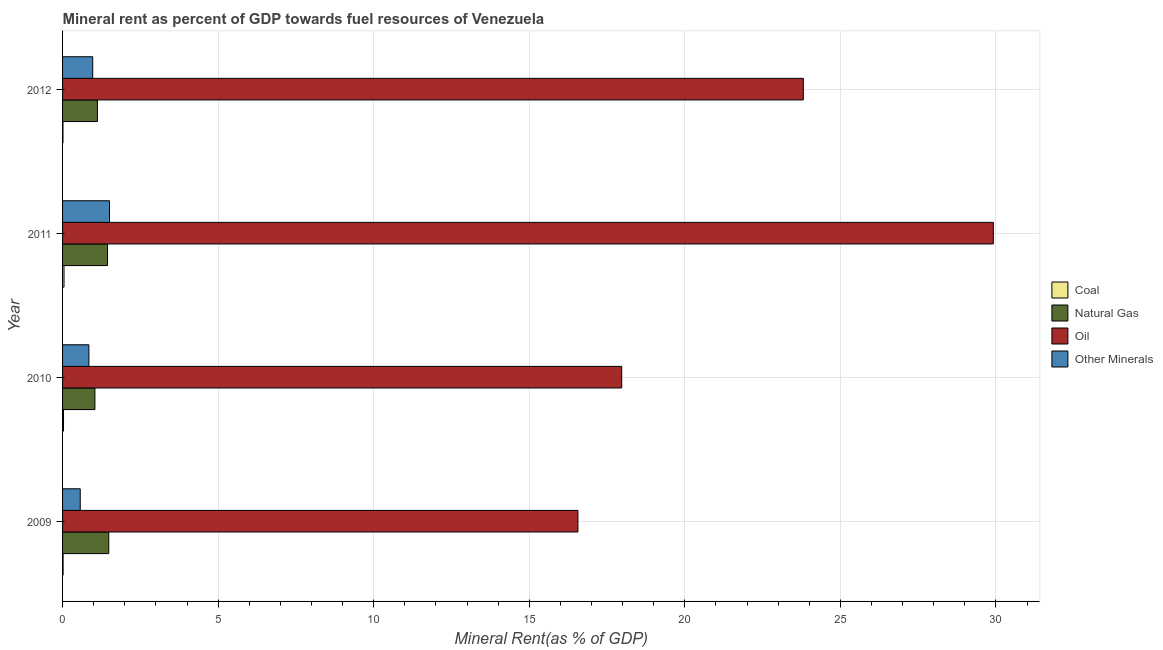How many bars are there on the 3rd tick from the top?
Offer a very short reply. 4. How many bars are there on the 1st tick from the bottom?
Ensure brevity in your answer.  4. In how many cases, is the number of bars for a given year not equal to the number of legend labels?
Your answer should be very brief. 0. What is the coal rent in 2010?
Make the answer very short. 0.03. Across all years, what is the maximum  rent of other minerals?
Keep it short and to the point. 1.51. Across all years, what is the minimum oil rent?
Keep it short and to the point. 16.57. In which year was the  rent of other minerals maximum?
Make the answer very short. 2011. What is the total natural gas rent in the graph?
Your answer should be very brief. 5.09. What is the difference between the natural gas rent in 2011 and that in 2012?
Offer a very short reply. 0.32. What is the difference between the oil rent in 2009 and the natural gas rent in 2010?
Give a very brief answer. 15.53. What is the average natural gas rent per year?
Keep it short and to the point. 1.27. In the year 2010, what is the difference between the oil rent and  rent of other minerals?
Your answer should be compact. 17.13. What is the ratio of the coal rent in 2010 to that in 2011?
Ensure brevity in your answer.  0.66. Is the difference between the coal rent in 2009 and 2011 greater than the difference between the  rent of other minerals in 2009 and 2011?
Keep it short and to the point. Yes. What is the difference between the highest and the second highest  rent of other minerals?
Provide a short and direct response. 0.54. What is the difference between the highest and the lowest  rent of other minerals?
Offer a terse response. 0.94. In how many years, is the coal rent greater than the average coal rent taken over all years?
Offer a terse response. 2. Is the sum of the  rent of other minerals in 2011 and 2012 greater than the maximum natural gas rent across all years?
Provide a short and direct response. Yes. What does the 3rd bar from the top in 2011 represents?
Ensure brevity in your answer.  Natural Gas. What does the 2nd bar from the bottom in 2010 represents?
Your answer should be very brief. Natural Gas. How many bars are there?
Your answer should be compact. 16. Are all the bars in the graph horizontal?
Offer a terse response. Yes. How many years are there in the graph?
Your answer should be very brief. 4. What is the difference between two consecutive major ticks on the X-axis?
Give a very brief answer. 5. Does the graph contain any zero values?
Your answer should be very brief. No. Does the graph contain grids?
Your answer should be compact. Yes. Where does the legend appear in the graph?
Provide a succinct answer. Center right. How many legend labels are there?
Keep it short and to the point. 4. What is the title of the graph?
Your answer should be compact. Mineral rent as percent of GDP towards fuel resources of Venezuela. What is the label or title of the X-axis?
Your response must be concise. Mineral Rent(as % of GDP). What is the label or title of the Y-axis?
Provide a short and direct response. Year. What is the Mineral Rent(as % of GDP) in Coal in 2009?
Provide a short and direct response. 0.02. What is the Mineral Rent(as % of GDP) in Natural Gas in 2009?
Keep it short and to the point. 1.48. What is the Mineral Rent(as % of GDP) in Oil in 2009?
Your response must be concise. 16.57. What is the Mineral Rent(as % of GDP) of Other Minerals in 2009?
Your response must be concise. 0.57. What is the Mineral Rent(as % of GDP) of Coal in 2010?
Ensure brevity in your answer.  0.03. What is the Mineral Rent(as % of GDP) of Natural Gas in 2010?
Make the answer very short. 1.04. What is the Mineral Rent(as % of GDP) in Oil in 2010?
Give a very brief answer. 17.97. What is the Mineral Rent(as % of GDP) of Other Minerals in 2010?
Make the answer very short. 0.85. What is the Mineral Rent(as % of GDP) of Coal in 2011?
Provide a succinct answer. 0.05. What is the Mineral Rent(as % of GDP) in Natural Gas in 2011?
Your response must be concise. 1.45. What is the Mineral Rent(as % of GDP) of Oil in 2011?
Ensure brevity in your answer.  29.92. What is the Mineral Rent(as % of GDP) in Other Minerals in 2011?
Provide a succinct answer. 1.51. What is the Mineral Rent(as % of GDP) of Coal in 2012?
Ensure brevity in your answer.  0.01. What is the Mineral Rent(as % of GDP) in Natural Gas in 2012?
Your answer should be very brief. 1.12. What is the Mineral Rent(as % of GDP) of Oil in 2012?
Make the answer very short. 23.81. What is the Mineral Rent(as % of GDP) in Other Minerals in 2012?
Offer a terse response. 0.97. Across all years, what is the maximum Mineral Rent(as % of GDP) of Coal?
Provide a short and direct response. 0.05. Across all years, what is the maximum Mineral Rent(as % of GDP) of Natural Gas?
Your answer should be very brief. 1.48. Across all years, what is the maximum Mineral Rent(as % of GDP) in Oil?
Ensure brevity in your answer.  29.92. Across all years, what is the maximum Mineral Rent(as % of GDP) of Other Minerals?
Your answer should be compact. 1.51. Across all years, what is the minimum Mineral Rent(as % of GDP) in Coal?
Ensure brevity in your answer.  0.01. Across all years, what is the minimum Mineral Rent(as % of GDP) of Natural Gas?
Offer a terse response. 1.04. Across all years, what is the minimum Mineral Rent(as % of GDP) in Oil?
Make the answer very short. 16.57. Across all years, what is the minimum Mineral Rent(as % of GDP) of Other Minerals?
Your answer should be very brief. 0.57. What is the total Mineral Rent(as % of GDP) of Coal in the graph?
Offer a terse response. 0.11. What is the total Mineral Rent(as % of GDP) of Natural Gas in the graph?
Your answer should be very brief. 5.09. What is the total Mineral Rent(as % of GDP) of Oil in the graph?
Give a very brief answer. 88.27. What is the total Mineral Rent(as % of GDP) of Other Minerals in the graph?
Give a very brief answer. 3.89. What is the difference between the Mineral Rent(as % of GDP) of Coal in 2009 and that in 2010?
Make the answer very short. -0.01. What is the difference between the Mineral Rent(as % of GDP) of Natural Gas in 2009 and that in 2010?
Your answer should be very brief. 0.45. What is the difference between the Mineral Rent(as % of GDP) in Oil in 2009 and that in 2010?
Provide a succinct answer. -1.41. What is the difference between the Mineral Rent(as % of GDP) in Other Minerals in 2009 and that in 2010?
Your answer should be compact. -0.28. What is the difference between the Mineral Rent(as % of GDP) of Coal in 2009 and that in 2011?
Offer a terse response. -0.03. What is the difference between the Mineral Rent(as % of GDP) in Natural Gas in 2009 and that in 2011?
Provide a short and direct response. 0.04. What is the difference between the Mineral Rent(as % of GDP) in Oil in 2009 and that in 2011?
Make the answer very short. -13.35. What is the difference between the Mineral Rent(as % of GDP) in Other Minerals in 2009 and that in 2011?
Provide a succinct answer. -0.94. What is the difference between the Mineral Rent(as % of GDP) in Coal in 2009 and that in 2012?
Give a very brief answer. 0. What is the difference between the Mineral Rent(as % of GDP) in Natural Gas in 2009 and that in 2012?
Make the answer very short. 0.36. What is the difference between the Mineral Rent(as % of GDP) in Oil in 2009 and that in 2012?
Your answer should be very brief. -7.24. What is the difference between the Mineral Rent(as % of GDP) in Other Minerals in 2009 and that in 2012?
Offer a very short reply. -0.4. What is the difference between the Mineral Rent(as % of GDP) in Coal in 2010 and that in 2011?
Provide a short and direct response. -0.02. What is the difference between the Mineral Rent(as % of GDP) of Natural Gas in 2010 and that in 2011?
Make the answer very short. -0.41. What is the difference between the Mineral Rent(as % of GDP) in Oil in 2010 and that in 2011?
Your answer should be very brief. -11.94. What is the difference between the Mineral Rent(as % of GDP) of Other Minerals in 2010 and that in 2011?
Provide a succinct answer. -0.66. What is the difference between the Mineral Rent(as % of GDP) in Coal in 2010 and that in 2012?
Provide a succinct answer. 0.02. What is the difference between the Mineral Rent(as % of GDP) in Natural Gas in 2010 and that in 2012?
Offer a very short reply. -0.08. What is the difference between the Mineral Rent(as % of GDP) in Oil in 2010 and that in 2012?
Offer a terse response. -5.84. What is the difference between the Mineral Rent(as % of GDP) of Other Minerals in 2010 and that in 2012?
Keep it short and to the point. -0.12. What is the difference between the Mineral Rent(as % of GDP) in Coal in 2011 and that in 2012?
Keep it short and to the point. 0.03. What is the difference between the Mineral Rent(as % of GDP) of Natural Gas in 2011 and that in 2012?
Your response must be concise. 0.32. What is the difference between the Mineral Rent(as % of GDP) in Oil in 2011 and that in 2012?
Your answer should be very brief. 6.11. What is the difference between the Mineral Rent(as % of GDP) in Other Minerals in 2011 and that in 2012?
Your response must be concise. 0.54. What is the difference between the Mineral Rent(as % of GDP) in Coal in 2009 and the Mineral Rent(as % of GDP) in Natural Gas in 2010?
Offer a terse response. -1.02. What is the difference between the Mineral Rent(as % of GDP) in Coal in 2009 and the Mineral Rent(as % of GDP) in Oil in 2010?
Provide a succinct answer. -17.95. What is the difference between the Mineral Rent(as % of GDP) in Coal in 2009 and the Mineral Rent(as % of GDP) in Other Minerals in 2010?
Offer a very short reply. -0.83. What is the difference between the Mineral Rent(as % of GDP) in Natural Gas in 2009 and the Mineral Rent(as % of GDP) in Oil in 2010?
Provide a short and direct response. -16.49. What is the difference between the Mineral Rent(as % of GDP) of Natural Gas in 2009 and the Mineral Rent(as % of GDP) of Other Minerals in 2010?
Ensure brevity in your answer.  0.64. What is the difference between the Mineral Rent(as % of GDP) in Oil in 2009 and the Mineral Rent(as % of GDP) in Other Minerals in 2010?
Give a very brief answer. 15.72. What is the difference between the Mineral Rent(as % of GDP) of Coal in 2009 and the Mineral Rent(as % of GDP) of Natural Gas in 2011?
Ensure brevity in your answer.  -1.43. What is the difference between the Mineral Rent(as % of GDP) of Coal in 2009 and the Mineral Rent(as % of GDP) of Oil in 2011?
Your answer should be very brief. -29.9. What is the difference between the Mineral Rent(as % of GDP) of Coal in 2009 and the Mineral Rent(as % of GDP) of Other Minerals in 2011?
Make the answer very short. -1.49. What is the difference between the Mineral Rent(as % of GDP) in Natural Gas in 2009 and the Mineral Rent(as % of GDP) in Oil in 2011?
Your answer should be compact. -28.43. What is the difference between the Mineral Rent(as % of GDP) of Natural Gas in 2009 and the Mineral Rent(as % of GDP) of Other Minerals in 2011?
Provide a short and direct response. -0.02. What is the difference between the Mineral Rent(as % of GDP) of Oil in 2009 and the Mineral Rent(as % of GDP) of Other Minerals in 2011?
Offer a very short reply. 15.06. What is the difference between the Mineral Rent(as % of GDP) of Coal in 2009 and the Mineral Rent(as % of GDP) of Natural Gas in 2012?
Make the answer very short. -1.1. What is the difference between the Mineral Rent(as % of GDP) in Coal in 2009 and the Mineral Rent(as % of GDP) in Oil in 2012?
Your answer should be very brief. -23.79. What is the difference between the Mineral Rent(as % of GDP) in Coal in 2009 and the Mineral Rent(as % of GDP) in Other Minerals in 2012?
Make the answer very short. -0.95. What is the difference between the Mineral Rent(as % of GDP) of Natural Gas in 2009 and the Mineral Rent(as % of GDP) of Oil in 2012?
Provide a short and direct response. -22.32. What is the difference between the Mineral Rent(as % of GDP) in Natural Gas in 2009 and the Mineral Rent(as % of GDP) in Other Minerals in 2012?
Your answer should be very brief. 0.52. What is the difference between the Mineral Rent(as % of GDP) in Oil in 2009 and the Mineral Rent(as % of GDP) in Other Minerals in 2012?
Offer a terse response. 15.6. What is the difference between the Mineral Rent(as % of GDP) of Coal in 2010 and the Mineral Rent(as % of GDP) of Natural Gas in 2011?
Make the answer very short. -1.42. What is the difference between the Mineral Rent(as % of GDP) in Coal in 2010 and the Mineral Rent(as % of GDP) in Oil in 2011?
Give a very brief answer. -29.89. What is the difference between the Mineral Rent(as % of GDP) in Coal in 2010 and the Mineral Rent(as % of GDP) in Other Minerals in 2011?
Provide a short and direct response. -1.48. What is the difference between the Mineral Rent(as % of GDP) of Natural Gas in 2010 and the Mineral Rent(as % of GDP) of Oil in 2011?
Ensure brevity in your answer.  -28.88. What is the difference between the Mineral Rent(as % of GDP) of Natural Gas in 2010 and the Mineral Rent(as % of GDP) of Other Minerals in 2011?
Offer a terse response. -0.47. What is the difference between the Mineral Rent(as % of GDP) in Oil in 2010 and the Mineral Rent(as % of GDP) in Other Minerals in 2011?
Keep it short and to the point. 16.46. What is the difference between the Mineral Rent(as % of GDP) of Coal in 2010 and the Mineral Rent(as % of GDP) of Natural Gas in 2012?
Your response must be concise. -1.09. What is the difference between the Mineral Rent(as % of GDP) of Coal in 2010 and the Mineral Rent(as % of GDP) of Oil in 2012?
Make the answer very short. -23.78. What is the difference between the Mineral Rent(as % of GDP) in Coal in 2010 and the Mineral Rent(as % of GDP) in Other Minerals in 2012?
Keep it short and to the point. -0.94. What is the difference between the Mineral Rent(as % of GDP) in Natural Gas in 2010 and the Mineral Rent(as % of GDP) in Oil in 2012?
Keep it short and to the point. -22.77. What is the difference between the Mineral Rent(as % of GDP) in Natural Gas in 2010 and the Mineral Rent(as % of GDP) in Other Minerals in 2012?
Your response must be concise. 0.07. What is the difference between the Mineral Rent(as % of GDP) in Oil in 2010 and the Mineral Rent(as % of GDP) in Other Minerals in 2012?
Offer a very short reply. 17. What is the difference between the Mineral Rent(as % of GDP) of Coal in 2011 and the Mineral Rent(as % of GDP) of Natural Gas in 2012?
Make the answer very short. -1.08. What is the difference between the Mineral Rent(as % of GDP) of Coal in 2011 and the Mineral Rent(as % of GDP) of Oil in 2012?
Ensure brevity in your answer.  -23.76. What is the difference between the Mineral Rent(as % of GDP) in Coal in 2011 and the Mineral Rent(as % of GDP) in Other Minerals in 2012?
Keep it short and to the point. -0.92. What is the difference between the Mineral Rent(as % of GDP) in Natural Gas in 2011 and the Mineral Rent(as % of GDP) in Oil in 2012?
Provide a short and direct response. -22.36. What is the difference between the Mineral Rent(as % of GDP) in Natural Gas in 2011 and the Mineral Rent(as % of GDP) in Other Minerals in 2012?
Offer a very short reply. 0.48. What is the difference between the Mineral Rent(as % of GDP) in Oil in 2011 and the Mineral Rent(as % of GDP) in Other Minerals in 2012?
Your answer should be compact. 28.95. What is the average Mineral Rent(as % of GDP) of Coal per year?
Provide a succinct answer. 0.03. What is the average Mineral Rent(as % of GDP) in Natural Gas per year?
Provide a short and direct response. 1.27. What is the average Mineral Rent(as % of GDP) of Oil per year?
Offer a terse response. 22.07. What is the average Mineral Rent(as % of GDP) of Other Minerals per year?
Offer a terse response. 0.97. In the year 2009, what is the difference between the Mineral Rent(as % of GDP) of Coal and Mineral Rent(as % of GDP) of Natural Gas?
Give a very brief answer. -1.47. In the year 2009, what is the difference between the Mineral Rent(as % of GDP) in Coal and Mineral Rent(as % of GDP) in Oil?
Give a very brief answer. -16.55. In the year 2009, what is the difference between the Mineral Rent(as % of GDP) in Coal and Mineral Rent(as % of GDP) in Other Minerals?
Provide a short and direct response. -0.55. In the year 2009, what is the difference between the Mineral Rent(as % of GDP) of Natural Gas and Mineral Rent(as % of GDP) of Oil?
Your answer should be very brief. -15.08. In the year 2009, what is the difference between the Mineral Rent(as % of GDP) in Natural Gas and Mineral Rent(as % of GDP) in Other Minerals?
Your answer should be compact. 0.92. In the year 2009, what is the difference between the Mineral Rent(as % of GDP) of Oil and Mineral Rent(as % of GDP) of Other Minerals?
Provide a short and direct response. 16. In the year 2010, what is the difference between the Mineral Rent(as % of GDP) in Coal and Mineral Rent(as % of GDP) in Natural Gas?
Ensure brevity in your answer.  -1.01. In the year 2010, what is the difference between the Mineral Rent(as % of GDP) of Coal and Mineral Rent(as % of GDP) of Oil?
Offer a very short reply. -17.94. In the year 2010, what is the difference between the Mineral Rent(as % of GDP) in Coal and Mineral Rent(as % of GDP) in Other Minerals?
Your answer should be very brief. -0.82. In the year 2010, what is the difference between the Mineral Rent(as % of GDP) of Natural Gas and Mineral Rent(as % of GDP) of Oil?
Make the answer very short. -16.93. In the year 2010, what is the difference between the Mineral Rent(as % of GDP) in Natural Gas and Mineral Rent(as % of GDP) in Other Minerals?
Offer a terse response. 0.19. In the year 2010, what is the difference between the Mineral Rent(as % of GDP) in Oil and Mineral Rent(as % of GDP) in Other Minerals?
Provide a succinct answer. 17.13. In the year 2011, what is the difference between the Mineral Rent(as % of GDP) in Coal and Mineral Rent(as % of GDP) in Natural Gas?
Your answer should be compact. -1.4. In the year 2011, what is the difference between the Mineral Rent(as % of GDP) of Coal and Mineral Rent(as % of GDP) of Oil?
Ensure brevity in your answer.  -29.87. In the year 2011, what is the difference between the Mineral Rent(as % of GDP) of Coal and Mineral Rent(as % of GDP) of Other Minerals?
Your answer should be very brief. -1.46. In the year 2011, what is the difference between the Mineral Rent(as % of GDP) of Natural Gas and Mineral Rent(as % of GDP) of Oil?
Offer a very short reply. -28.47. In the year 2011, what is the difference between the Mineral Rent(as % of GDP) in Natural Gas and Mineral Rent(as % of GDP) in Other Minerals?
Your answer should be very brief. -0.06. In the year 2011, what is the difference between the Mineral Rent(as % of GDP) of Oil and Mineral Rent(as % of GDP) of Other Minerals?
Your answer should be very brief. 28.41. In the year 2012, what is the difference between the Mineral Rent(as % of GDP) of Coal and Mineral Rent(as % of GDP) of Natural Gas?
Your response must be concise. -1.11. In the year 2012, what is the difference between the Mineral Rent(as % of GDP) in Coal and Mineral Rent(as % of GDP) in Oil?
Offer a terse response. -23.8. In the year 2012, what is the difference between the Mineral Rent(as % of GDP) in Coal and Mineral Rent(as % of GDP) in Other Minerals?
Provide a succinct answer. -0.96. In the year 2012, what is the difference between the Mineral Rent(as % of GDP) in Natural Gas and Mineral Rent(as % of GDP) in Oil?
Give a very brief answer. -22.69. In the year 2012, what is the difference between the Mineral Rent(as % of GDP) in Natural Gas and Mineral Rent(as % of GDP) in Other Minerals?
Provide a short and direct response. 0.15. In the year 2012, what is the difference between the Mineral Rent(as % of GDP) of Oil and Mineral Rent(as % of GDP) of Other Minerals?
Your answer should be compact. 22.84. What is the ratio of the Mineral Rent(as % of GDP) in Coal in 2009 to that in 2010?
Your answer should be compact. 0.58. What is the ratio of the Mineral Rent(as % of GDP) in Natural Gas in 2009 to that in 2010?
Make the answer very short. 1.43. What is the ratio of the Mineral Rent(as % of GDP) of Oil in 2009 to that in 2010?
Your answer should be compact. 0.92. What is the ratio of the Mineral Rent(as % of GDP) of Other Minerals in 2009 to that in 2010?
Make the answer very short. 0.67. What is the ratio of the Mineral Rent(as % of GDP) of Coal in 2009 to that in 2011?
Offer a terse response. 0.38. What is the ratio of the Mineral Rent(as % of GDP) in Natural Gas in 2009 to that in 2011?
Offer a terse response. 1.03. What is the ratio of the Mineral Rent(as % of GDP) of Oil in 2009 to that in 2011?
Provide a short and direct response. 0.55. What is the ratio of the Mineral Rent(as % of GDP) in Other Minerals in 2009 to that in 2011?
Give a very brief answer. 0.38. What is the ratio of the Mineral Rent(as % of GDP) of Coal in 2009 to that in 2012?
Provide a succinct answer. 1.36. What is the ratio of the Mineral Rent(as % of GDP) of Natural Gas in 2009 to that in 2012?
Your answer should be very brief. 1.32. What is the ratio of the Mineral Rent(as % of GDP) of Oil in 2009 to that in 2012?
Your answer should be compact. 0.7. What is the ratio of the Mineral Rent(as % of GDP) of Other Minerals in 2009 to that in 2012?
Give a very brief answer. 0.59. What is the ratio of the Mineral Rent(as % of GDP) of Coal in 2010 to that in 2011?
Give a very brief answer. 0.66. What is the ratio of the Mineral Rent(as % of GDP) in Natural Gas in 2010 to that in 2011?
Provide a succinct answer. 0.72. What is the ratio of the Mineral Rent(as % of GDP) of Oil in 2010 to that in 2011?
Keep it short and to the point. 0.6. What is the ratio of the Mineral Rent(as % of GDP) in Other Minerals in 2010 to that in 2011?
Provide a short and direct response. 0.56. What is the ratio of the Mineral Rent(as % of GDP) in Coal in 2010 to that in 2012?
Ensure brevity in your answer.  2.35. What is the ratio of the Mineral Rent(as % of GDP) of Natural Gas in 2010 to that in 2012?
Offer a terse response. 0.93. What is the ratio of the Mineral Rent(as % of GDP) in Oil in 2010 to that in 2012?
Offer a very short reply. 0.75. What is the ratio of the Mineral Rent(as % of GDP) in Other Minerals in 2010 to that in 2012?
Offer a very short reply. 0.87. What is the ratio of the Mineral Rent(as % of GDP) of Coal in 2011 to that in 2012?
Provide a short and direct response. 3.58. What is the ratio of the Mineral Rent(as % of GDP) of Natural Gas in 2011 to that in 2012?
Keep it short and to the point. 1.29. What is the ratio of the Mineral Rent(as % of GDP) of Oil in 2011 to that in 2012?
Ensure brevity in your answer.  1.26. What is the ratio of the Mineral Rent(as % of GDP) of Other Minerals in 2011 to that in 2012?
Keep it short and to the point. 1.56. What is the difference between the highest and the second highest Mineral Rent(as % of GDP) of Coal?
Make the answer very short. 0.02. What is the difference between the highest and the second highest Mineral Rent(as % of GDP) in Natural Gas?
Your answer should be very brief. 0.04. What is the difference between the highest and the second highest Mineral Rent(as % of GDP) in Oil?
Provide a succinct answer. 6.11. What is the difference between the highest and the second highest Mineral Rent(as % of GDP) of Other Minerals?
Your answer should be compact. 0.54. What is the difference between the highest and the lowest Mineral Rent(as % of GDP) of Coal?
Provide a succinct answer. 0.03. What is the difference between the highest and the lowest Mineral Rent(as % of GDP) in Natural Gas?
Offer a very short reply. 0.45. What is the difference between the highest and the lowest Mineral Rent(as % of GDP) in Oil?
Make the answer very short. 13.35. What is the difference between the highest and the lowest Mineral Rent(as % of GDP) in Other Minerals?
Your answer should be compact. 0.94. 